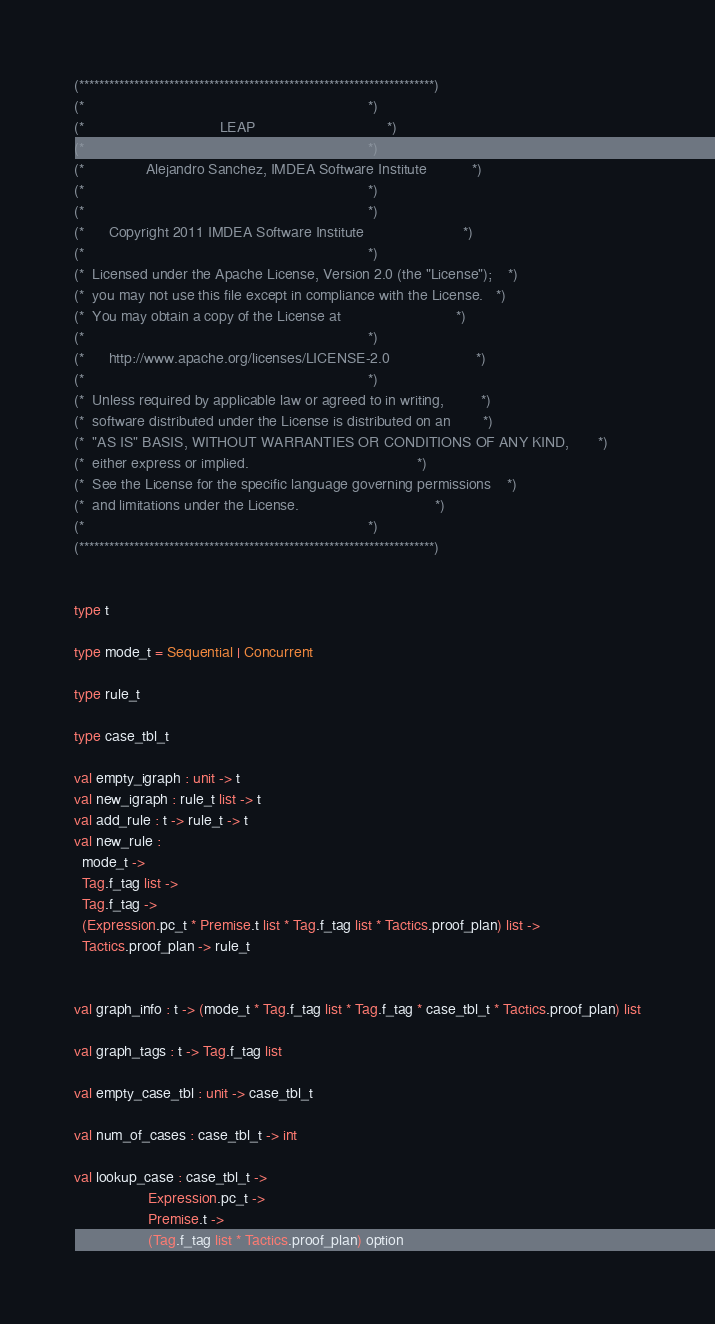Convert code to text. <code><loc_0><loc_0><loc_500><loc_500><_OCaml_>
(***********************************************************************)
(*                                                                     *)
(*                                 LEAP                                *)
(*                                                                     *)
(*               Alejandro Sanchez, IMDEA Software Institute           *)
(*                                                                     *)
(*                                                                     *)
(*      Copyright 2011 IMDEA Software Institute                        *)
(*                                                                     *)
(*  Licensed under the Apache License, Version 2.0 (the "License");    *)
(*  you may not use this file except in compliance with the License.   *)
(*  You may obtain a copy of the License at                            *)
(*                                                                     *)
(*      http://www.apache.org/licenses/LICENSE-2.0                     *)
(*                                                                     *)
(*  Unless required by applicable law or agreed to in writing,         *)
(*  software distributed under the License is distributed on an        *)
(*  "AS IS" BASIS, WITHOUT WARRANTIES OR CONDITIONS OF ANY KIND,       *)
(*  either express or implied.                                         *)
(*  See the License for the specific language governing permissions    *)
(*  and limitations under the License.                                 *)
(*                                                                     *)
(***********************************************************************)


type t

type mode_t = Sequential | Concurrent

type rule_t

type case_tbl_t

val empty_igraph : unit -> t
val new_igraph : rule_t list -> t
val add_rule : t -> rule_t -> t
val new_rule :
  mode_t ->
  Tag.f_tag list ->
  Tag.f_tag ->
  (Expression.pc_t * Premise.t list * Tag.f_tag list * Tactics.proof_plan) list ->
  Tactics.proof_plan -> rule_t


val graph_info : t -> (mode_t * Tag.f_tag list * Tag.f_tag * case_tbl_t * Tactics.proof_plan) list

val graph_tags : t -> Tag.f_tag list

val empty_case_tbl : unit -> case_tbl_t

val num_of_cases : case_tbl_t -> int

val lookup_case : case_tbl_t ->
                  Expression.pc_t ->
                  Premise.t ->
                  (Tag.f_tag list * Tactics.proof_plan) option
</code> 